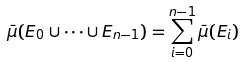Convert formula to latex. <formula><loc_0><loc_0><loc_500><loc_500>\bar { \mu } ( E _ { 0 } \cup \cdots \cup E _ { n - 1 } ) = \sum _ { i = 0 } ^ { n - 1 } \bar { \mu } ( E _ { i } )</formula> 